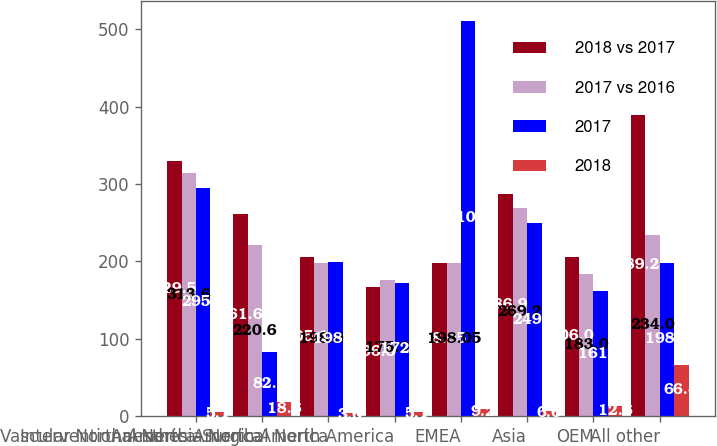<chart> <loc_0><loc_0><loc_500><loc_500><stacked_bar_chart><ecel><fcel>Vascular North America<fcel>Interventional North America<fcel>Anesthesia North America<fcel>Surgical North America<fcel>EMEA<fcel>Asia<fcel>OEM<fcel>All other<nl><fcel>2018 vs 2017<fcel>329.5<fcel>261.6<fcel>205.1<fcel>166.3<fcel>198.05<fcel>286.9<fcel>206<fcel>389.2<nl><fcel>2017 vs 2016<fcel>313.6<fcel>220.6<fcel>198<fcel>175.2<fcel>198.05<fcel>269.2<fcel>183<fcel>234<nl><fcel>2017<fcel>295.2<fcel>82.4<fcel>198.8<fcel>172.2<fcel>510.9<fcel>249.4<fcel>161<fcel>198.1<nl><fcel>2018<fcel>5.1<fcel>18.6<fcel>3.6<fcel>5.1<fcel>9.2<fcel>6.6<fcel>12.6<fcel>66.4<nl></chart> 